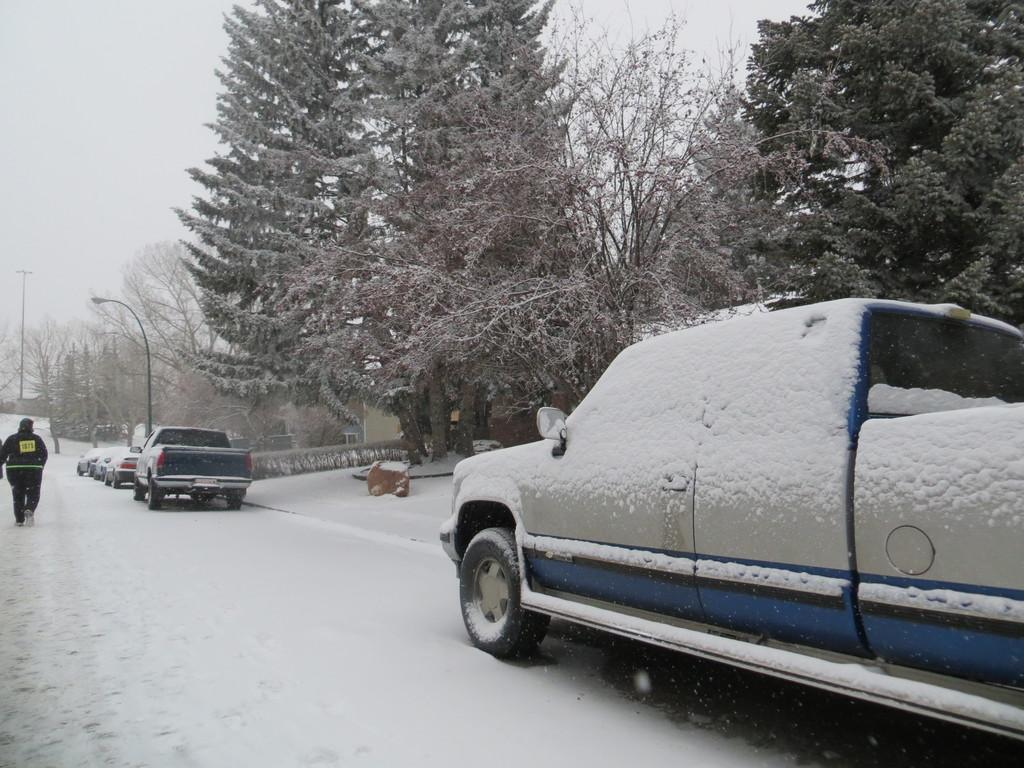What is covering the vehicle on the right side of the image? There is snow on a vehicle on the right side of the image. What is the person on the left side of the image doing? A person is walking on the left side of the image. What type of vegetation is in the middle of the image? There are green trees in the middle of the image. What theory is the person on the left side of the image discussing with the trees in the middle of the image? There is no indication in the image that the person is discussing a theory with the trees, as trees do not engage in discussions. What type of zinc is present in the image? There is no zinc present in the image. 